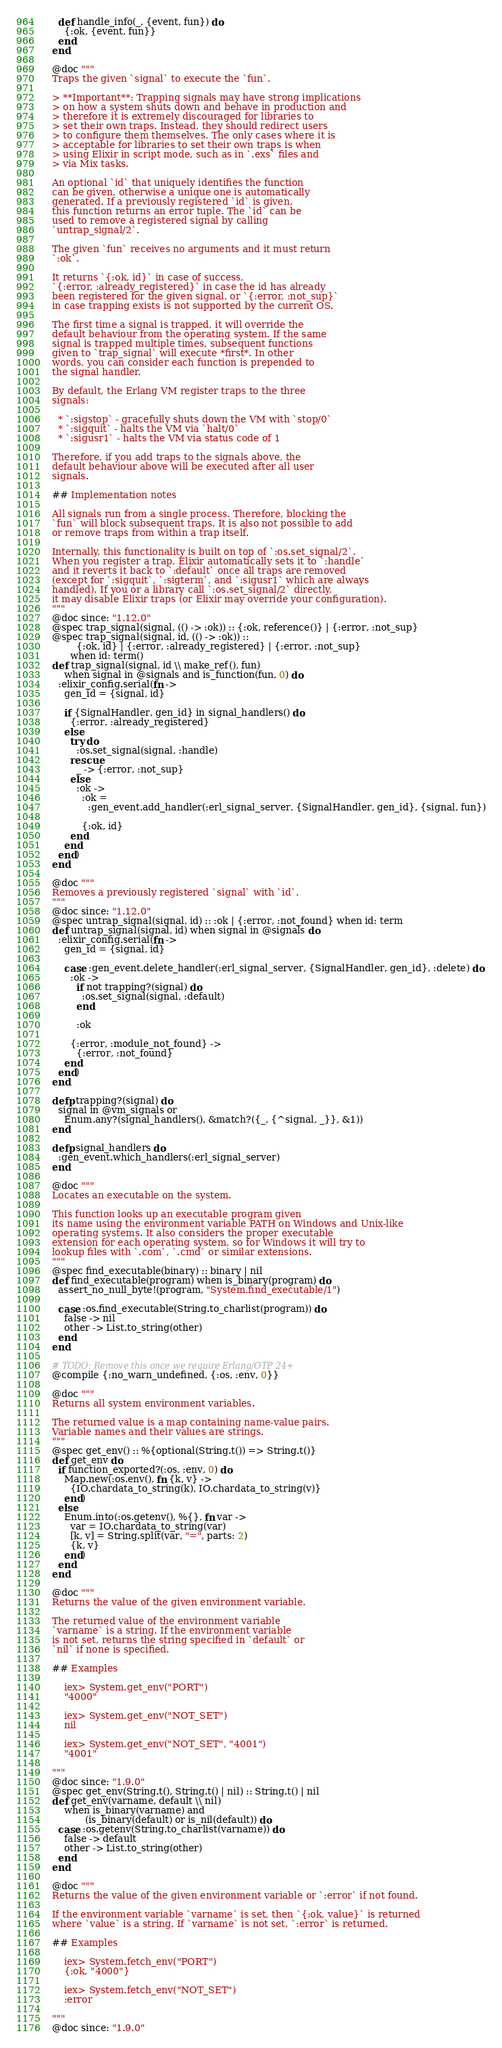Convert code to text. <code><loc_0><loc_0><loc_500><loc_500><_Elixir_>    def handle_info(_, {event, fun}) do
      {:ok, {event, fun}}
    end
  end

  @doc """
  Traps the given `signal` to execute the `fun`.

  > **Important**: Trapping signals may have strong implications
  > on how a system shuts down and behave in production and
  > therefore it is extremely discouraged for libraries to
  > set their own traps. Instead, they should redirect users
  > to configure them themselves. The only cases where it is
  > acceptable for libraries to set their own traps is when
  > using Elixir in script mode, such as in `.exs` files and
  > via Mix tasks.

  An optional `id` that uniquely identifies the function
  can be given, otherwise a unique one is automatically
  generated. If a previously registered `id` is given,
  this function returns an error tuple. The `id` can be
  used to remove a registered signal by calling
  `untrap_signal/2`.

  The given `fun` receives no arguments and it must return
  `:ok`.

  It returns `{:ok, id}` in case of success,
  `{:error, :already_registered}` in case the id has already
  been registered for the given signal, or `{:error, :not_sup}`
  in case trapping exists is not supported by the current OS.

  The first time a signal is trapped, it will override the
  default behaviour from the operating system. If the same
  signal is trapped multiple times, subsequent functions
  given to `trap_signal` will execute *first*. In other
  words, you can consider each function is prepended to
  the signal handler.

  By default, the Erlang VM register traps to the three
  signals:

    * `:sigstop` - gracefully shuts down the VM with `stop/0`
    * `:sigquit` - halts the VM via `halt/0`
    * `:sigusr1` - halts the VM via status code of 1

  Therefore, if you add traps to the signals above, the
  default behaviour above will be executed after all user
  signals.

  ## Implementation notes

  All signals run from a single process. Therefore, blocking the
  `fun` will block subsequent traps. It is also not possible to add
  or remove traps from within a trap itself.

  Internally, this functionality is built on top of `:os.set_signal/2`.
  When you register a trap, Elixir automatically sets it to `:handle`
  and it reverts it back to `:default` once all traps are removed
  (except for `:sigquit`, `:sigterm`, and `:sigusr1` which are always
  handled). If you or a library call `:os.set_signal/2` directly,
  it may disable Elixir traps (or Elixir may override your configuration).
  """
  @doc since: "1.12.0"
  @spec trap_signal(signal, (() -> :ok)) :: {:ok, reference()} | {:error, :not_sup}
  @spec trap_signal(signal, id, (() -> :ok)) ::
          {:ok, id} | {:error, :already_registered} | {:error, :not_sup}
        when id: term()
  def trap_signal(signal, id \\ make_ref(), fun)
      when signal in @signals and is_function(fun, 0) do
    :elixir_config.serial(fn ->
      gen_id = {signal, id}

      if {SignalHandler, gen_id} in signal_handlers() do
        {:error, :already_registered}
      else
        try do
          :os.set_signal(signal, :handle)
        rescue
          _ -> {:error, :not_sup}
        else
          :ok ->
            :ok =
              :gen_event.add_handler(:erl_signal_server, {SignalHandler, gen_id}, {signal, fun})

            {:ok, id}
        end
      end
    end)
  end

  @doc """
  Removes a previously registered `signal` with `id`.
  """
  @doc since: "1.12.0"
  @spec untrap_signal(signal, id) :: :ok | {:error, :not_found} when id: term
  def untrap_signal(signal, id) when signal in @signals do
    :elixir_config.serial(fn ->
      gen_id = {signal, id}

      case :gen_event.delete_handler(:erl_signal_server, {SignalHandler, gen_id}, :delete) do
        :ok ->
          if not trapping?(signal) do
            :os.set_signal(signal, :default)
          end

          :ok

        {:error, :module_not_found} ->
          {:error, :not_found}
      end
    end)
  end

  defp trapping?(signal) do
    signal in @vm_signals or
      Enum.any?(signal_handlers(), &match?({_, {^signal, _}}, &1))
  end

  defp signal_handlers do
    :gen_event.which_handlers(:erl_signal_server)
  end

  @doc """
  Locates an executable on the system.

  This function looks up an executable program given
  its name using the environment variable PATH on Windows and Unix-like
  operating systems. It also considers the proper executable
  extension for each operating system, so for Windows it will try to
  lookup files with `.com`, `.cmd` or similar extensions.
  """
  @spec find_executable(binary) :: binary | nil
  def find_executable(program) when is_binary(program) do
    assert_no_null_byte!(program, "System.find_executable/1")

    case :os.find_executable(String.to_charlist(program)) do
      false -> nil
      other -> List.to_string(other)
    end
  end

  # TODO: Remove this once we require Erlang/OTP 24+
  @compile {:no_warn_undefined, {:os, :env, 0}}

  @doc """
  Returns all system environment variables.

  The returned value is a map containing name-value pairs.
  Variable names and their values are strings.
  """
  @spec get_env() :: %{optional(String.t()) => String.t()}
  def get_env do
    if function_exported?(:os, :env, 0) do
      Map.new(:os.env(), fn {k, v} ->
        {IO.chardata_to_string(k), IO.chardata_to_string(v)}
      end)
    else
      Enum.into(:os.getenv(), %{}, fn var ->
        var = IO.chardata_to_string(var)
        [k, v] = String.split(var, "=", parts: 2)
        {k, v}
      end)
    end
  end

  @doc """
  Returns the value of the given environment variable.

  The returned value of the environment variable
  `varname` is a string. If the environment variable
  is not set, returns the string specified in `default` or
  `nil` if none is specified.

  ## Examples

      iex> System.get_env("PORT")
      "4000"

      iex> System.get_env("NOT_SET")
      nil

      iex> System.get_env("NOT_SET", "4001")
      "4001"

  """
  @doc since: "1.9.0"
  @spec get_env(String.t(), String.t() | nil) :: String.t() | nil
  def get_env(varname, default \\ nil)
      when is_binary(varname) and
             (is_binary(default) or is_nil(default)) do
    case :os.getenv(String.to_charlist(varname)) do
      false -> default
      other -> List.to_string(other)
    end
  end

  @doc """
  Returns the value of the given environment variable or `:error` if not found.

  If the environment variable `varname` is set, then `{:ok, value}` is returned
  where `value` is a string. If `varname` is not set, `:error` is returned.

  ## Examples

      iex> System.fetch_env("PORT")
      {:ok, "4000"}

      iex> System.fetch_env("NOT_SET")
      :error

  """
  @doc since: "1.9.0"</code> 